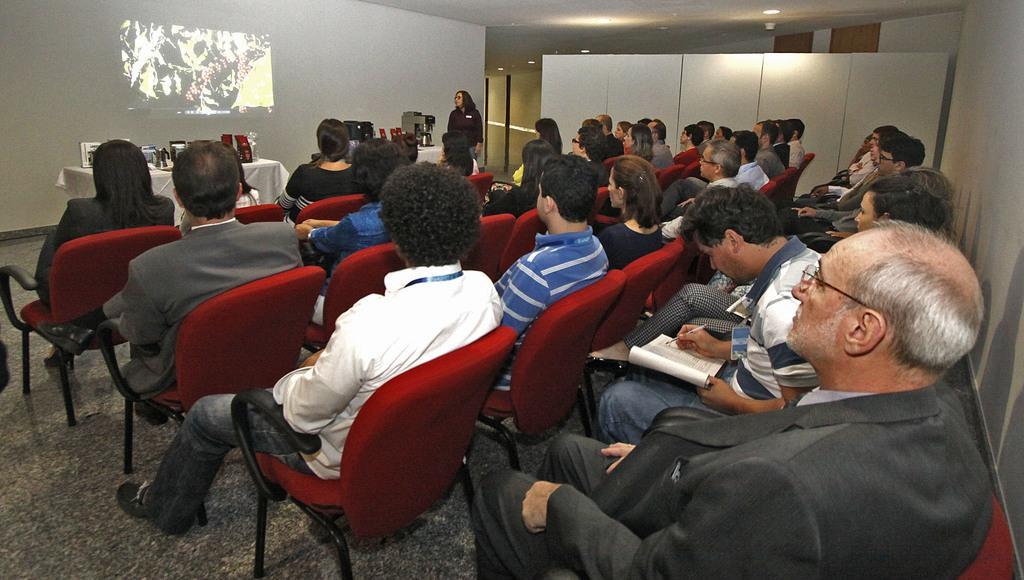What is the main subject of the image? The main subject of the image is a group of people. What are the people in the image doing? The people are sitting on a chair and watching a screen. What type of powder can be seen being used by the people in the image? There is no powder present in the image; the people are simply sitting on a chair and watching a screen. What type of tin object is visible in the image? There is no tin object present in the image. 